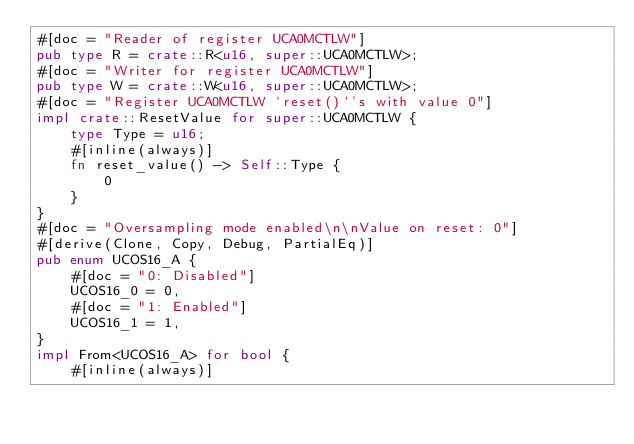Convert code to text. <code><loc_0><loc_0><loc_500><loc_500><_Rust_>#[doc = "Reader of register UCA0MCTLW"]
pub type R = crate::R<u16, super::UCA0MCTLW>;
#[doc = "Writer for register UCA0MCTLW"]
pub type W = crate::W<u16, super::UCA0MCTLW>;
#[doc = "Register UCA0MCTLW `reset()`'s with value 0"]
impl crate::ResetValue for super::UCA0MCTLW {
    type Type = u16;
    #[inline(always)]
    fn reset_value() -> Self::Type {
        0
    }
}
#[doc = "Oversampling mode enabled\n\nValue on reset: 0"]
#[derive(Clone, Copy, Debug, PartialEq)]
pub enum UCOS16_A {
    #[doc = "0: Disabled"]
    UCOS16_0 = 0,
    #[doc = "1: Enabled"]
    UCOS16_1 = 1,
}
impl From<UCOS16_A> for bool {
    #[inline(always)]</code> 